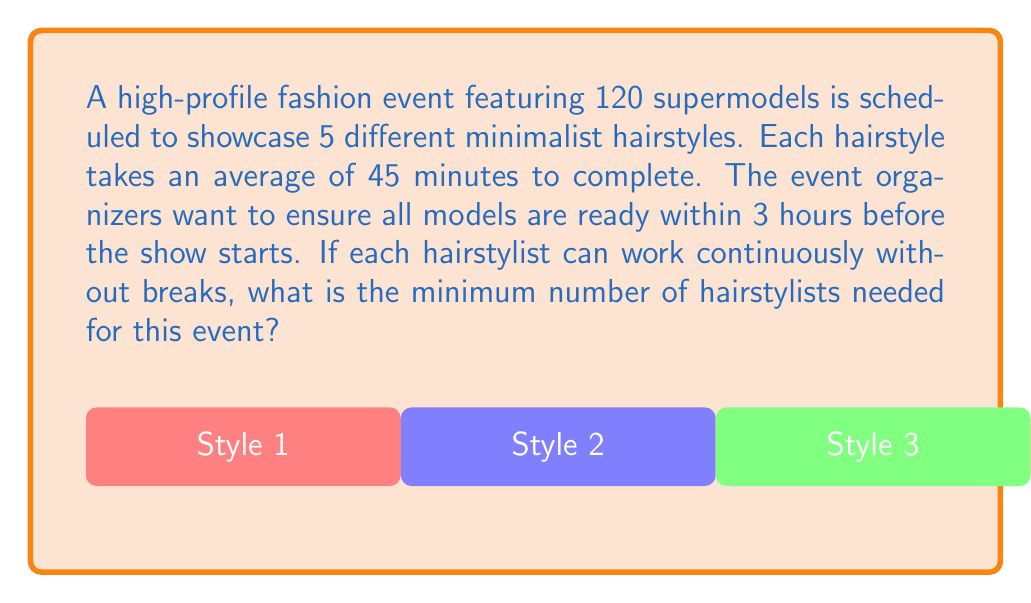Solve this math problem. Let's approach this problem step-by-step:

1. Calculate the total number of hairstyles to be done:
   $$ \text{Total hairstyles} = \text{Number of models} \times \text{Styles per model} = 120 \times 5 = 600 $$

2. Calculate the total time needed to complete all hairstyles:
   $$ \text{Total time} = \text{Total hairstyles} \times \text{Time per hairstyle} = 600 \times 45 \text{ minutes} = 27,000 \text{ minutes} $$

3. Convert the available time (3 hours) to minutes:
   $$ \text{Available time} = 3 \text{ hours} \times 60 \text{ minutes/hour} = 180 \text{ minutes} $$

4. Calculate the total stylist-minutes needed:
   $$ \text{Stylist-minutes needed} = 27,000 \text{ minutes} $$

5. Calculate the number of stylists needed:
   $$ \text{Number of stylists} = \frac{\text{Stylist-minutes needed}}{\text{Available time}} = \frac{27,000}{180} = 150 $$

6. Since we can't have a fractional number of stylists, we round up to the nearest whole number:
   $$ \text{Minimum number of stylists} = \lceil 150 \rceil = 150 $$

Therefore, the minimum number of hairstylists needed is 150.
Answer: 150 hairstylists 